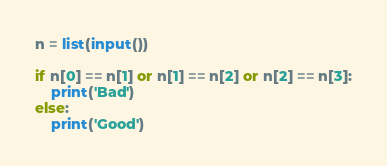Convert code to text. <code><loc_0><loc_0><loc_500><loc_500><_Python_>n = list(input())

if n[0] == n[1] or n[1] == n[2] or n[2] == n[3]:
    print('Bad')
else:
    print('Good')
</code> 